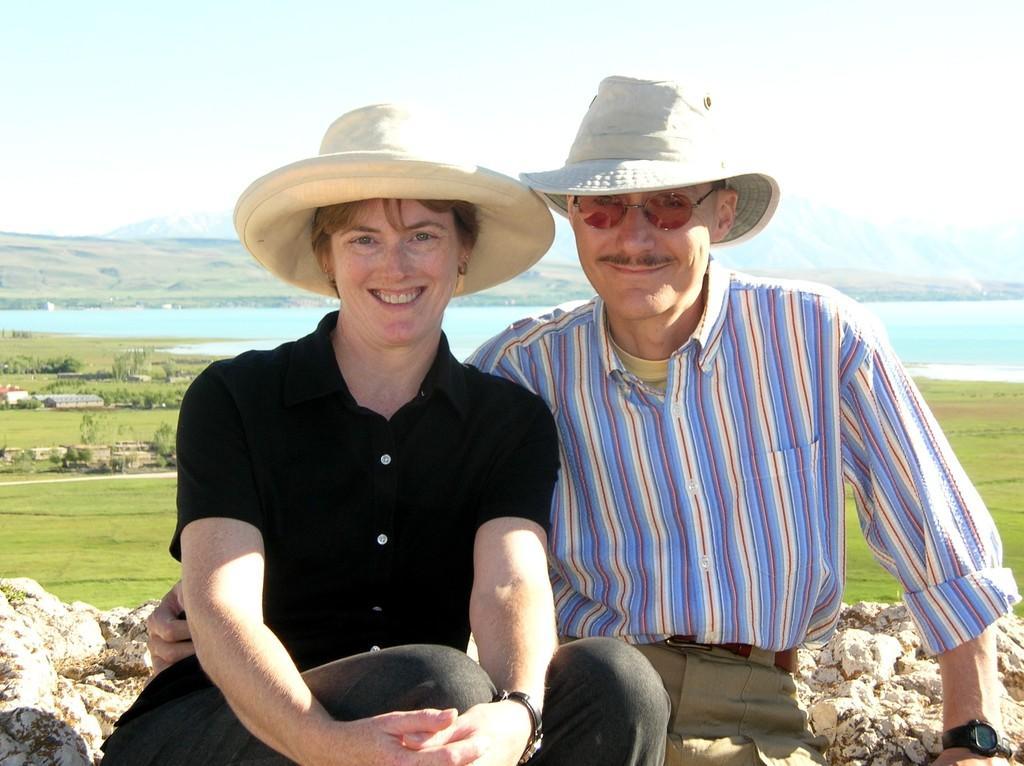Could you give a brief overview of what you see in this image? This is the man and woman sitting and smiling. They wore hats, shirts, trousers and wrist watches. This is the rock. These are the houses and trees. I can see the grass. In the background, that looks like water. 